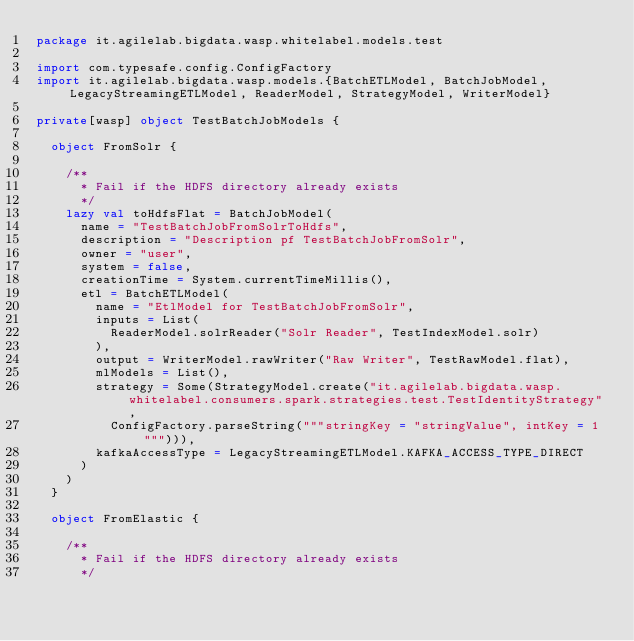<code> <loc_0><loc_0><loc_500><loc_500><_Scala_>package it.agilelab.bigdata.wasp.whitelabel.models.test

import com.typesafe.config.ConfigFactory
import it.agilelab.bigdata.wasp.models.{BatchETLModel, BatchJobModel, LegacyStreamingETLModel, ReaderModel, StrategyModel, WriterModel}

private[wasp] object TestBatchJobModels {

  object FromSolr {

    /**
      * Fail if the HDFS directory already exists
      */
    lazy val toHdfsFlat = BatchJobModel(
      name = "TestBatchJobFromSolrToHdfs",
      description = "Description pf TestBatchJobFromSolr",
      owner = "user",
      system = false,
      creationTime = System.currentTimeMillis(),
      etl = BatchETLModel(
        name = "EtlModel for TestBatchJobFromSolr",
        inputs = List(
          ReaderModel.solrReader("Solr Reader", TestIndexModel.solr)
        ),
        output = WriterModel.rawWriter("Raw Writer", TestRawModel.flat),
        mlModels = List(),
        strategy = Some(StrategyModel.create("it.agilelab.bigdata.wasp.whitelabel.consumers.spark.strategies.test.TestIdentityStrategy",
          ConfigFactory.parseString("""stringKey = "stringValue", intKey = 1"""))),
        kafkaAccessType = LegacyStreamingETLModel.KAFKA_ACCESS_TYPE_DIRECT
      )
    )
  }

  object FromElastic {

    /**
      * Fail if the HDFS directory already exists
      */</code> 